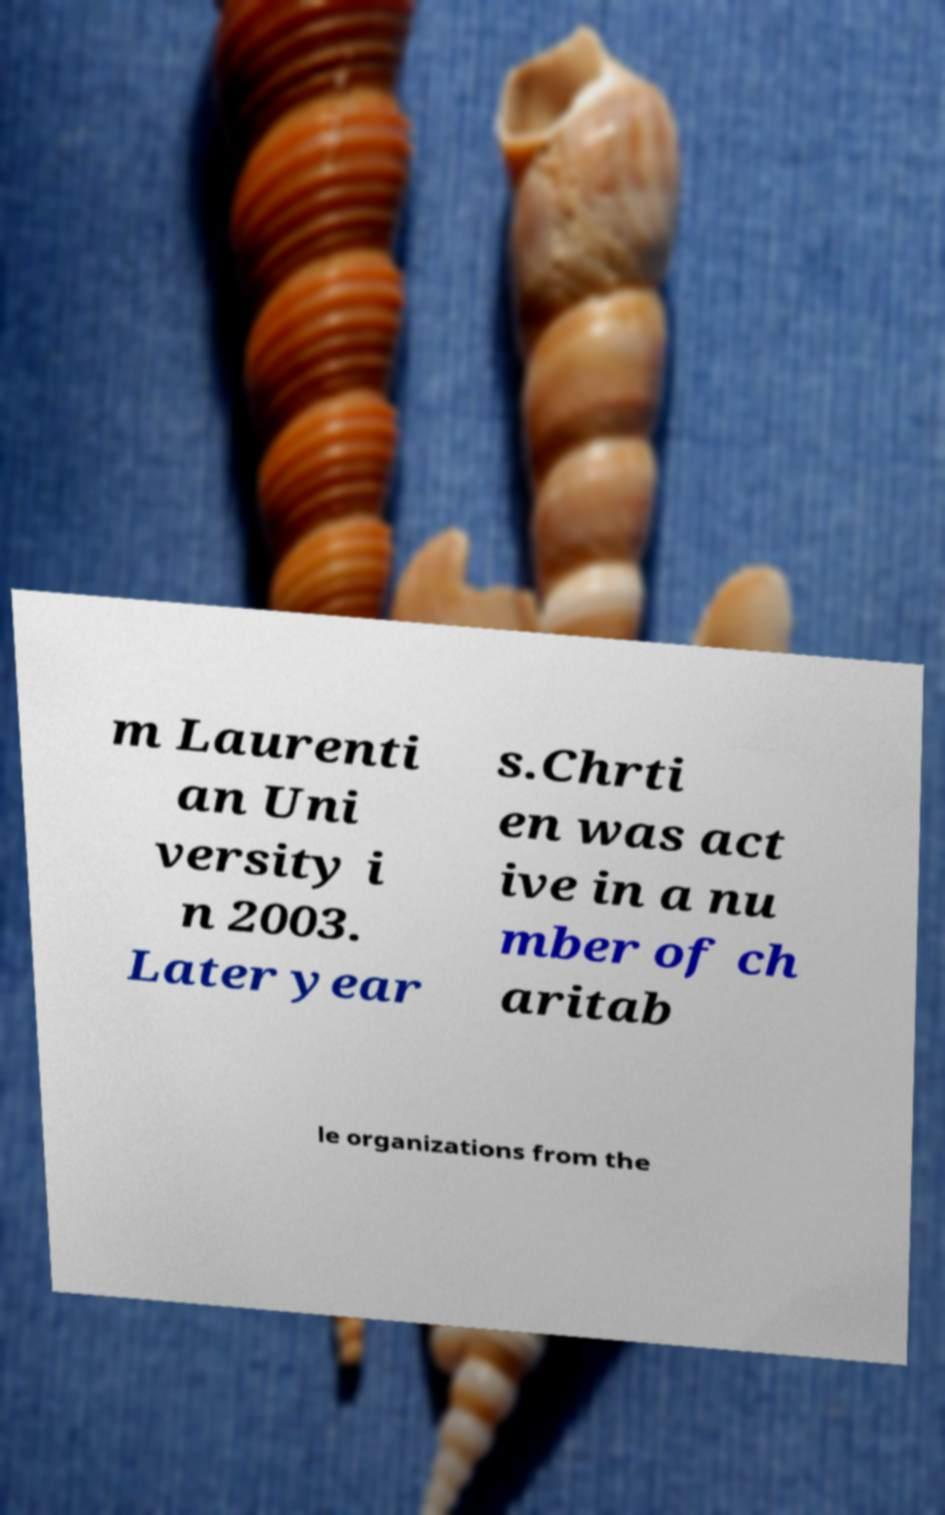Could you assist in decoding the text presented in this image and type it out clearly? m Laurenti an Uni versity i n 2003. Later year s.Chrti en was act ive in a nu mber of ch aritab le organizations from the 